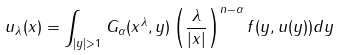Convert formula to latex. <formula><loc_0><loc_0><loc_500><loc_500>u _ { \lambda } ( x ) = \int _ { | y | > 1 } G _ { \alpha } ( x ^ { \lambda } , y ) \left ( \frac { \lambda } { | x | } \right ) ^ { n - \alpha } f ( y , u ( y ) ) d y</formula> 